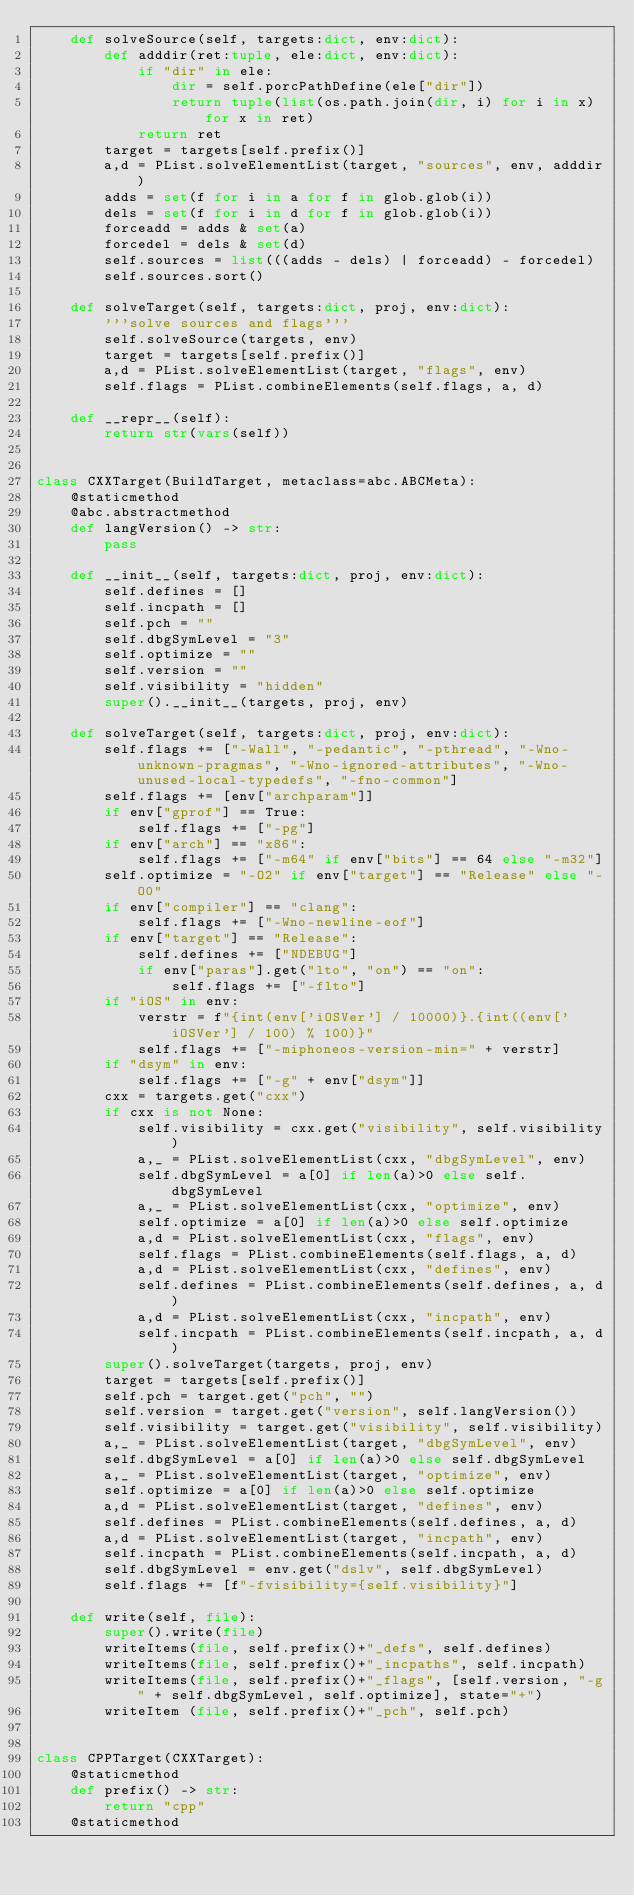Convert code to text. <code><loc_0><loc_0><loc_500><loc_500><_Python_>    def solveSource(self, targets:dict, env:dict):
        def adddir(ret:tuple, ele:dict, env:dict):
            if "dir" in ele:
                dir = self.porcPathDefine(ele["dir"])
                return tuple(list(os.path.join(dir, i) for i in x) for x in ret)
            return ret
        target = targets[self.prefix()]
        a,d = PList.solveElementList(target, "sources", env, adddir)
        adds = set(f for i in a for f in glob.glob(i))
        dels = set(f for i in d for f in glob.glob(i))
        forceadd = adds & set(a)
        forcedel = dels & set(d)
        self.sources = list(((adds - dels) | forceadd) - forcedel)
        self.sources.sort()

    def solveTarget(self, targets:dict, proj, env:dict):
        '''solve sources and flags'''
        self.solveSource(targets, env)
        target = targets[self.prefix()]
        a,d = PList.solveElementList(target, "flags", env)
        self.flags = PList.combineElements(self.flags, a, d)

    def __repr__(self):
        return str(vars(self))


class CXXTarget(BuildTarget, metaclass=abc.ABCMeta):
    @staticmethod
    @abc.abstractmethod
    def langVersion() -> str:
        pass

    def __init__(self, targets:dict, proj, env:dict):
        self.defines = []
        self.incpath = []
        self.pch = ""
        self.dbgSymLevel = "3"
        self.optimize = ""
        self.version = ""
        self.visibility = "hidden"
        super().__init__(targets, proj, env)

    def solveTarget(self, targets:dict, proj, env:dict):
        self.flags += ["-Wall", "-pedantic", "-pthread", "-Wno-unknown-pragmas", "-Wno-ignored-attributes", "-Wno-unused-local-typedefs", "-fno-common"]
        self.flags += [env["archparam"]]
        if env["gprof"] == True:
            self.flags += ["-pg"]
        if env["arch"] == "x86":
            self.flags += ["-m64" if env["bits"] == 64 else "-m32"]
        self.optimize = "-O2" if env["target"] == "Release" else "-O0"
        if env["compiler"] == "clang":
            self.flags += ["-Wno-newline-eof"]
        if env["target"] == "Release":
            self.defines += ["NDEBUG"]
            if env["paras"].get("lto", "on") == "on":
                self.flags += ["-flto"]
        if "iOS" in env:
            verstr = f"{int(env['iOSVer'] / 10000)}.{int((env['iOSVer'] / 100) % 100)}"
            self.flags += ["-miphoneos-version-min=" + verstr]
        if "dsym" in env:
            self.flags += ["-g" + env["dsym"]]
        cxx = targets.get("cxx")
        if cxx is not None:
            self.visibility = cxx.get("visibility", self.visibility)
            a,_ = PList.solveElementList(cxx, "dbgSymLevel", env)
            self.dbgSymLevel = a[0] if len(a)>0 else self.dbgSymLevel
            a,_ = PList.solveElementList(cxx, "optimize", env)
            self.optimize = a[0] if len(a)>0 else self.optimize
            a,d = PList.solveElementList(cxx, "flags", env)
            self.flags = PList.combineElements(self.flags, a, d)
            a,d = PList.solveElementList(cxx, "defines", env)
            self.defines = PList.combineElements(self.defines, a, d)
            a,d = PList.solveElementList(cxx, "incpath", env)
            self.incpath = PList.combineElements(self.incpath, a, d)
        super().solveTarget(targets, proj, env)
        target = targets[self.prefix()]
        self.pch = target.get("pch", "")
        self.version = target.get("version", self.langVersion())
        self.visibility = target.get("visibility", self.visibility)
        a,_ = PList.solveElementList(target, "dbgSymLevel", env)
        self.dbgSymLevel = a[0] if len(a)>0 else self.dbgSymLevel
        a,_ = PList.solveElementList(target, "optimize", env)
        self.optimize = a[0] if len(a)>0 else self.optimize
        a,d = PList.solveElementList(target, "defines", env)
        self.defines = PList.combineElements(self.defines, a, d)
        a,d = PList.solveElementList(target, "incpath", env)
        self.incpath = PList.combineElements(self.incpath, a, d)
        self.dbgSymLevel = env.get("dslv", self.dbgSymLevel)
        self.flags += [f"-fvisibility={self.visibility}"]

    def write(self, file):
        super().write(file)
        writeItems(file, self.prefix()+"_defs", self.defines)
        writeItems(file, self.prefix()+"_incpaths", self.incpath)
        writeItems(file, self.prefix()+"_flags", [self.version, "-g" + self.dbgSymLevel, self.optimize], state="+")
        writeItem (file, self.prefix()+"_pch", self.pch)


class CPPTarget(CXXTarget):
    @staticmethod
    def prefix() -> str:
        return "cpp"
    @staticmethod</code> 